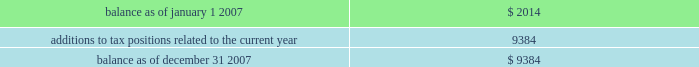Ventas , inc .
Notes to consolidated financial statements 2014 ( continued ) we have a combined nol carryforward of $ 66.5 million at december 31 , 2007 related to the trs entities and an nol carryforward reported by the reit of $ 88.6 million .
These amounts can be used to offset future taxable income ( and/or taxable income for prior years if audits of any prior year 2019s return determine that amounts are owed ) , if any .
The reit will be entitled to utilize nols and tax credit carryforwards only to the extent that reit taxable income exceeds our deduction for dividends paid .
The nol carryforwards begin to expire in 2024 with respect to the trs entities and in 2018 for the reit .
As a result of the uncertainties relating to the ultimate utilization of existing reit nols , no net deferred tax benefit has been ascribed to reit nol carryforwards as of december 31 , 2007 and 2006 .
The irs may challenge our entitlement to these tax attributes during its review of the tax returns for the previous tax years .
We believe we are entitled to these tax attributes , but we cannot assure you as to the outcome of these matters .
On january 1 , 2007 , we adopted fin 48 .
As a result of applying the provisions of fin 48 , we recognized no change in the liability for unrecognized tax benefits , and no adjustment in accumulated earnings as of january 1 , 2007 .
Our policy is to recognize interest and penalties related to unrecognized tax benefits in income tax expense .
The table summarizes the activity related to our unrecognized tax benefits ( in thousands ) : .
Included in the unrecognized tax benefits of $ 9.4 million at december 31 , 2007 was $ 9.4 million of tax benefits that , if recognized , would reduce our annual effective tax rate .
We accrued no potential penalties and interest related to the unrecognized tax benefits during 2007 , and in total , as of december 31 , 2007 , we have recorded no liability for potential penalties and interest .
We expect our unrecognized tax benefits to increase by $ 2.7 million during 2008 .
Note 13 2014commitments and contingencies assumption of certain operating liabilities and litigation as a result of the structure of the sunrise reit acquisition , we may be subject to various liabilities of sunrise reit arising out of the ownership or operation of the sunrise reit properties prior to the acquisition .
If the liabilities we have assumed are greater than expected , or if there are obligations relating to the sunrise reit properties of which we were not aware at the time of completion of the sunrise reit acquisition , such liabilities and/or obligations could have a material adverse effect on us .
In connection with our spin off of kindred in 1998 , kindred agreed , among other things , to assume all liabilities and to indemnify , defend and hold us harmless from and against certain losses , claims and litigation arising out of the ownership or operation of the healthcare operations or any of the assets transferred to kindred in the spin off , including without limitation all claims arising out of the third-party leases and third-party guarantees assigned to and assumed by kindred at the time of the spin off .
Under kindred 2019s plan of reorganization , kindred assumed and agreed to fulfill these obligations .
The total aggregate remaining minimum rental payments under the third-party leases was approximately $ 16.0 million as of december 31 , 2007 , and we believe that we had no material exposure under the third-party guarantees .
Similarly , in connection with provident 2019s acquisition of certain brookdale-related and alterra-related entities in 2005 and our subsequent acquisition of provident , brookdale and alterra agreed , among other things .
What was the anticipated balance of in unrecognized tax benefits in 2008 in millions? 
Rationale: the balances in unrecognized tax benefits are both stated as 9.4 and 2.7 the sum of which equals 12.1
Computations: (9.4 + 2.7)
Answer: 12.1. 